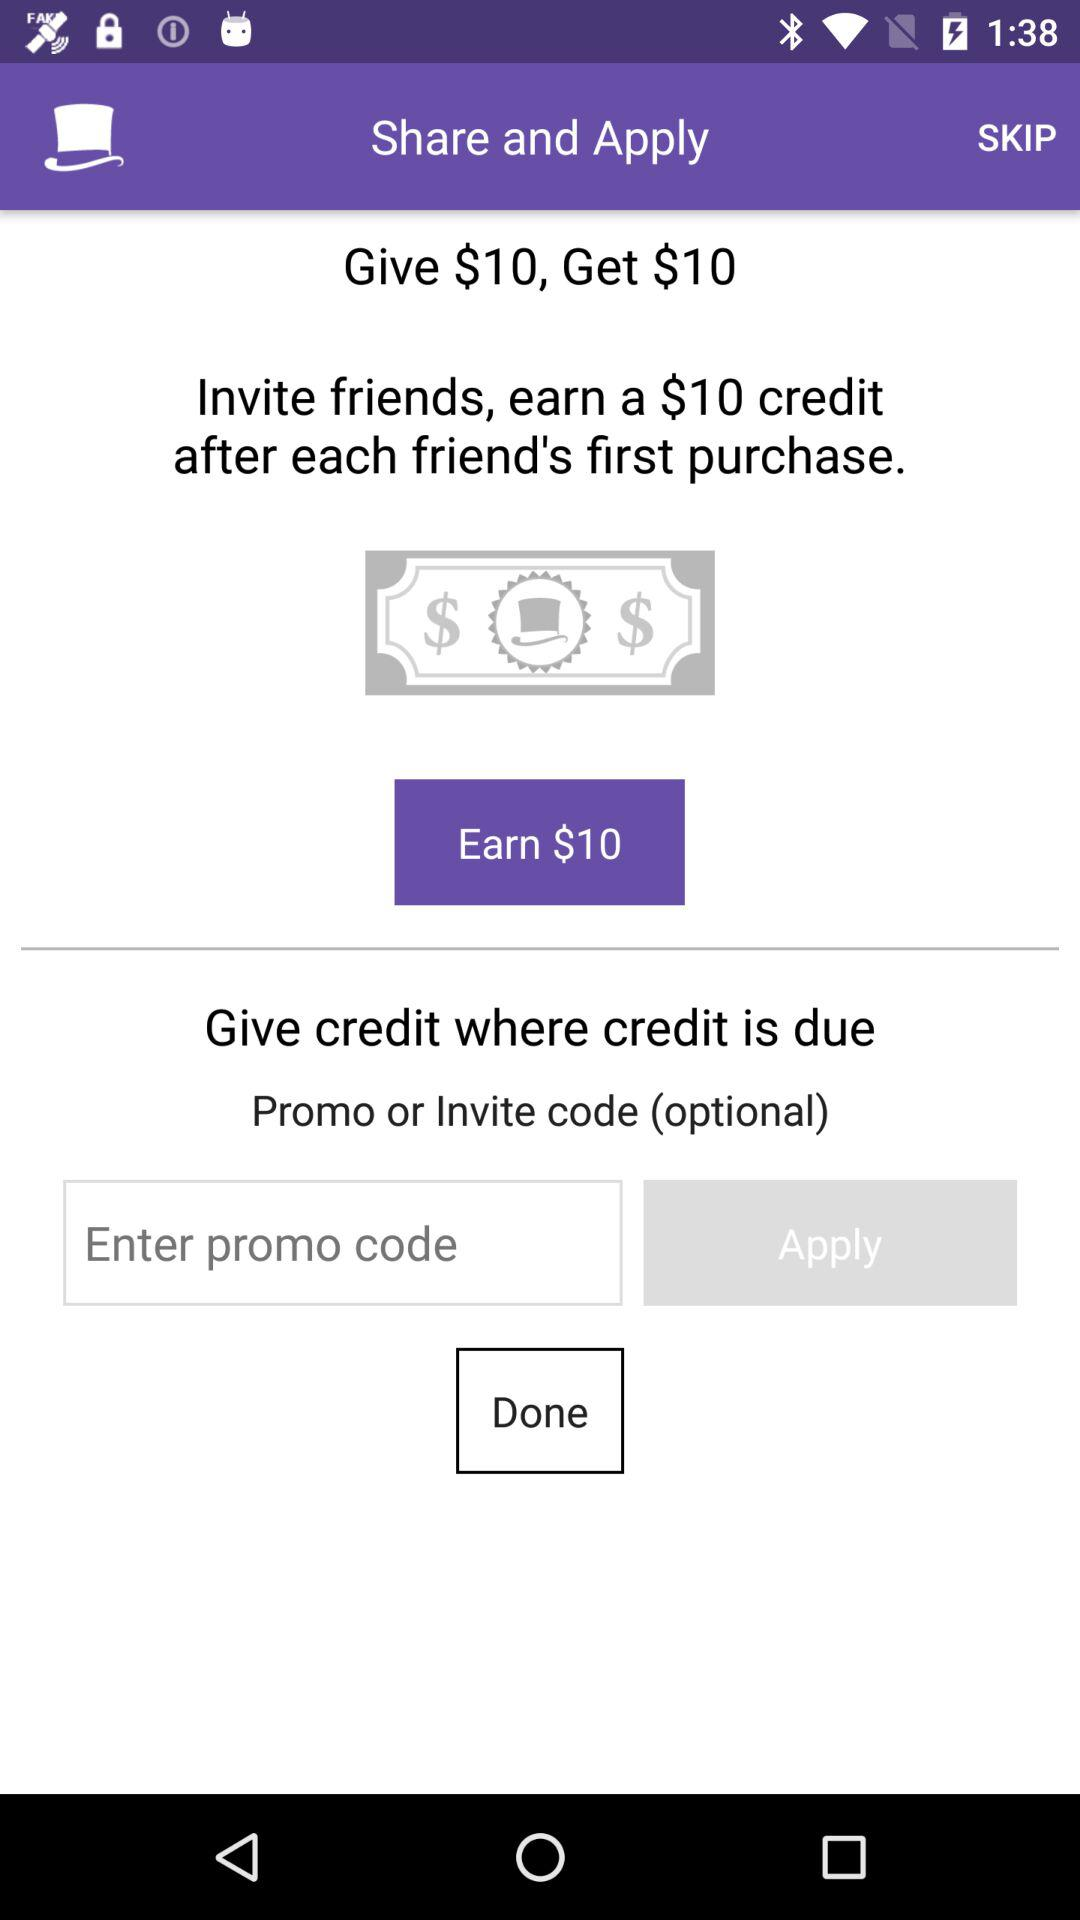How much money can I earn if I invite 5 friends?
Answer the question using a single word or phrase. $50 